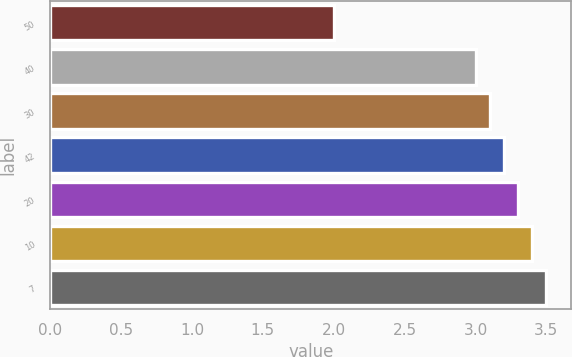Convert chart to OTSL. <chart><loc_0><loc_0><loc_500><loc_500><bar_chart><fcel>50<fcel>40<fcel>30<fcel>42<fcel>20<fcel>10<fcel>7<nl><fcel>2<fcel>3<fcel>3.1<fcel>3.2<fcel>3.3<fcel>3.4<fcel>3.5<nl></chart> 